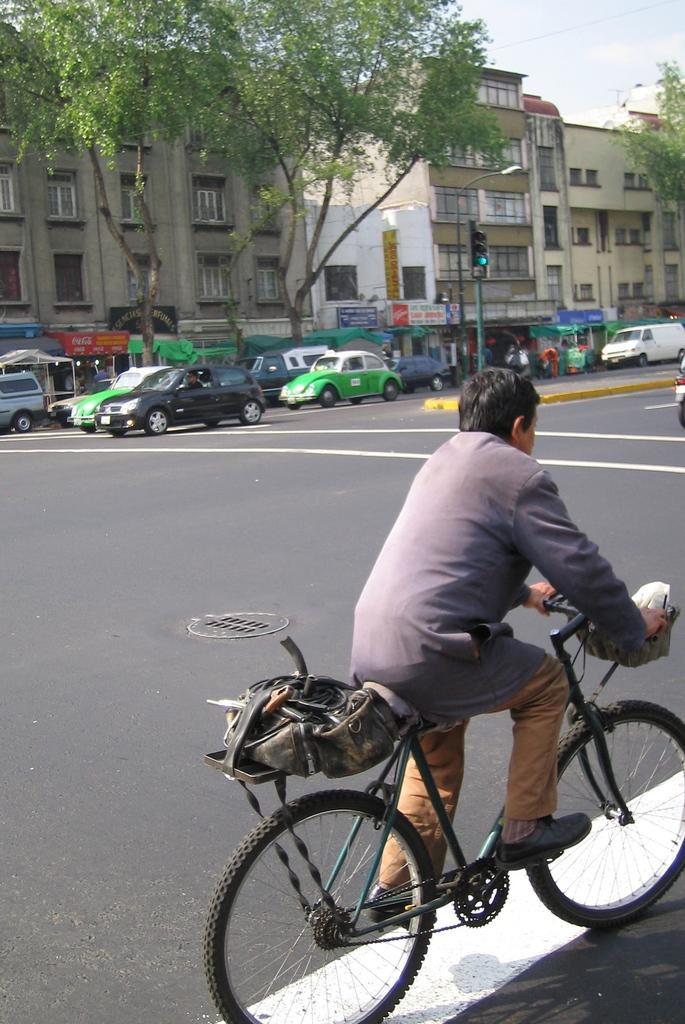How would you summarize this image in a sentence or two? In this picture we can see a man is riding bicycle on the road, in the background we can see couple of cars on the road and also we can see trees, couple of buildings and poles. 